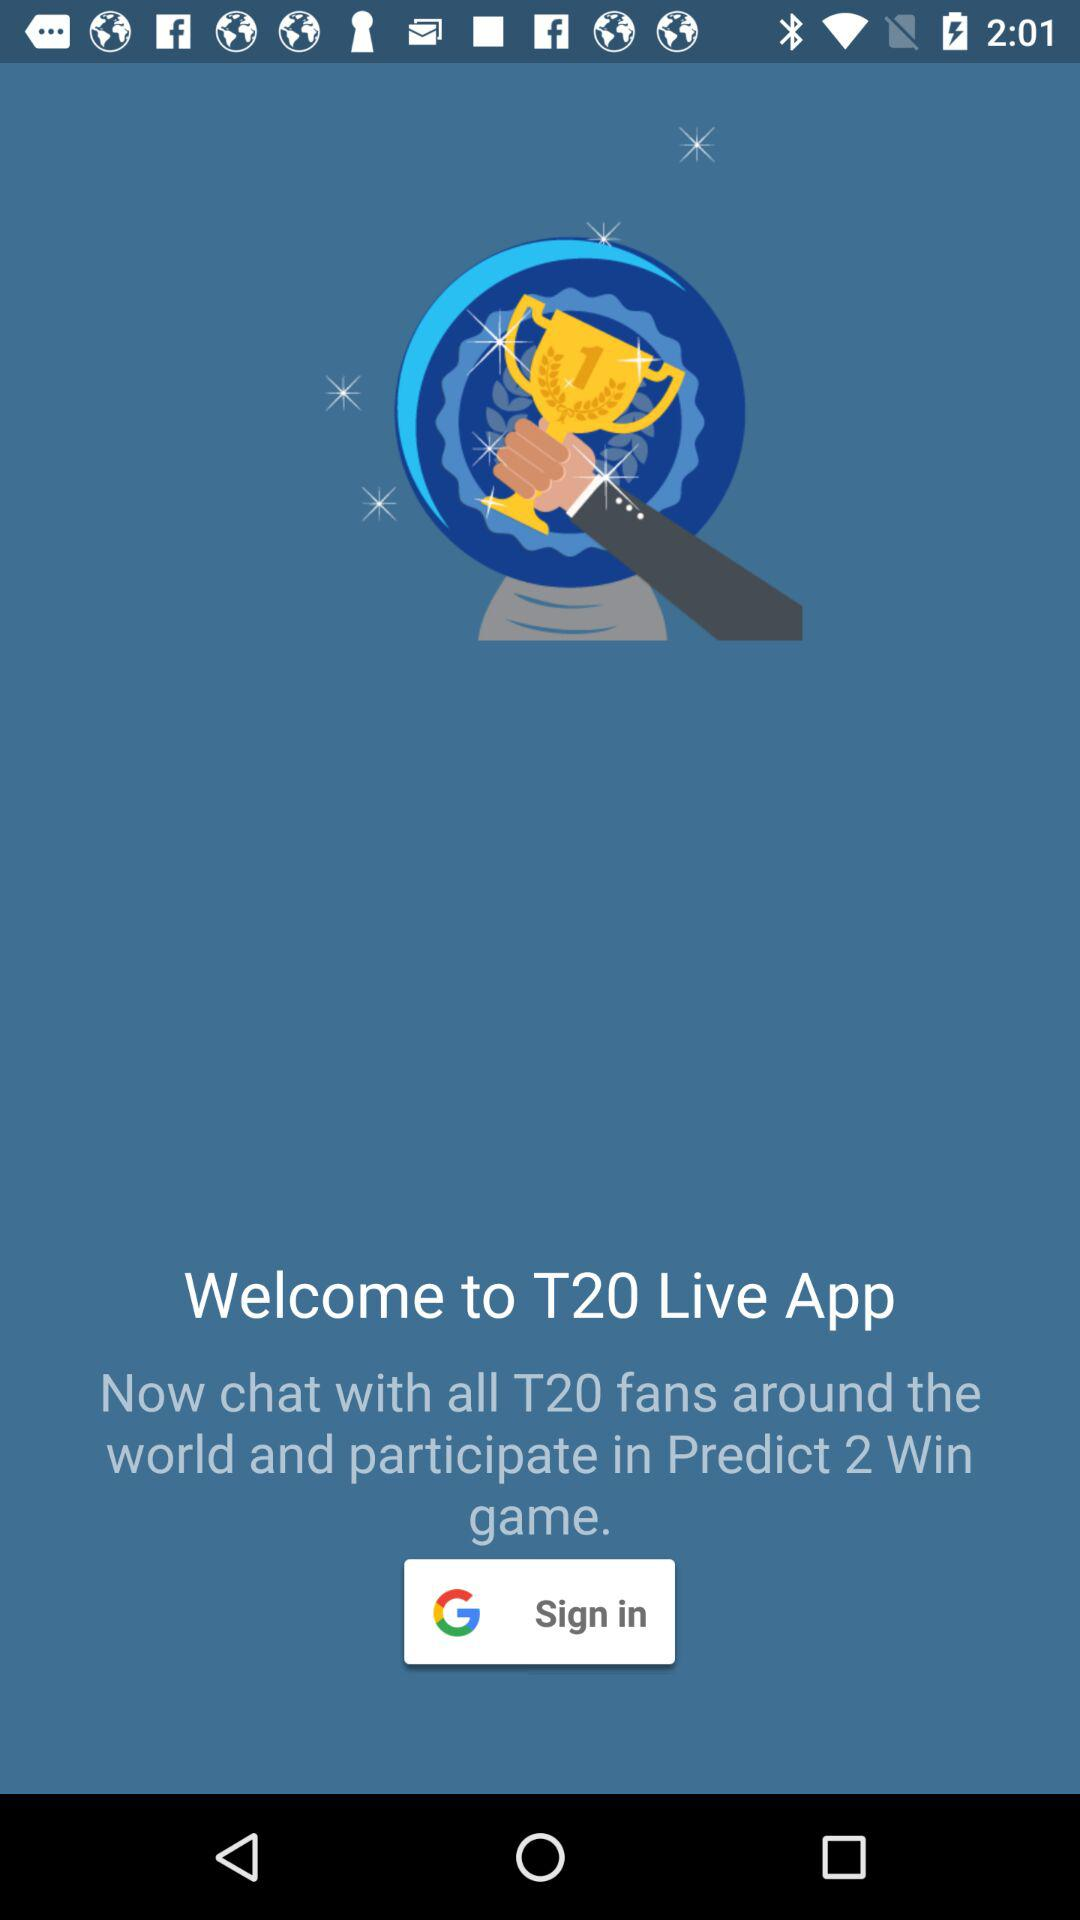How many game can we predict?
When the provided information is insufficient, respond with <no answer>. <no answer> 